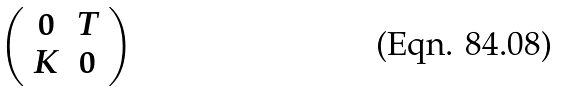<formula> <loc_0><loc_0><loc_500><loc_500>\left ( \begin{array} { c c } 0 & T \\ K & 0 \end{array} \right )</formula> 